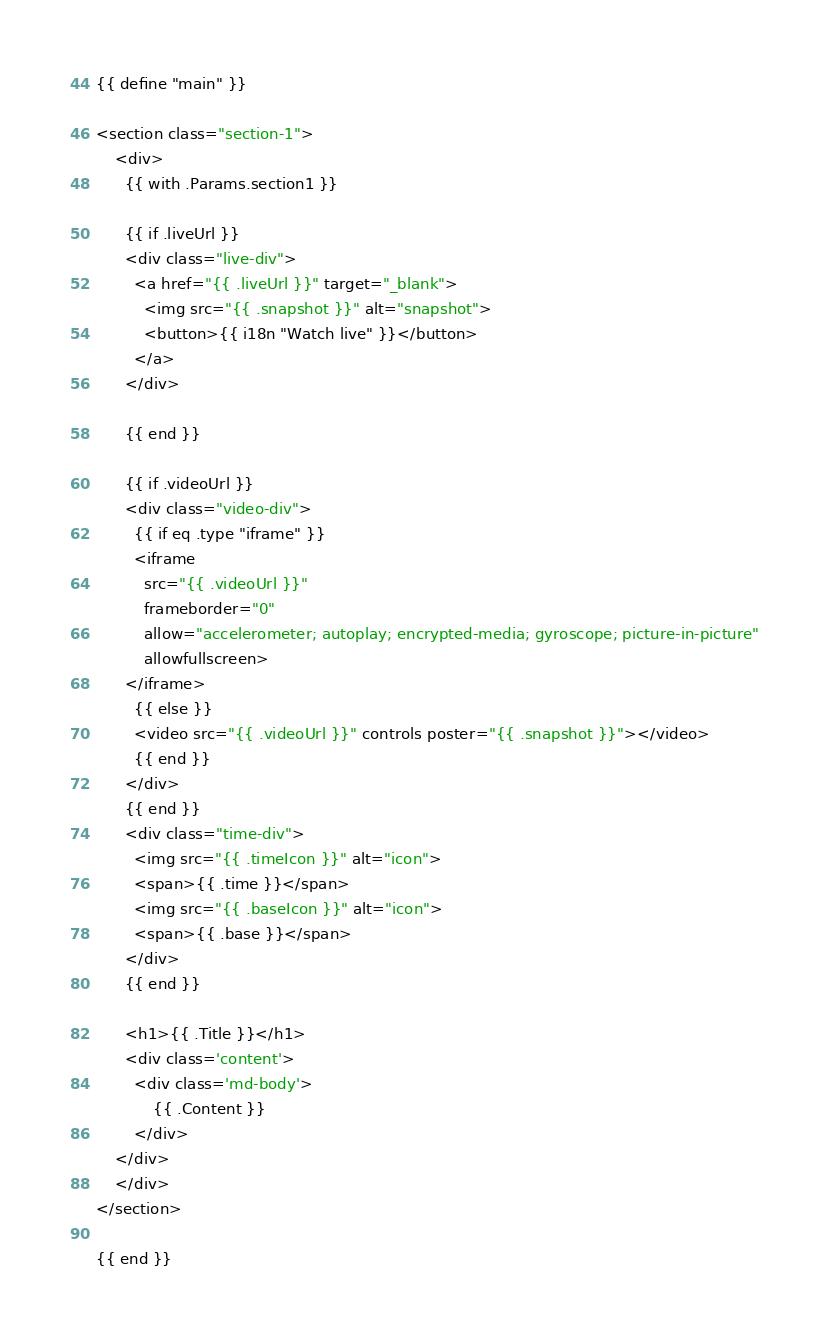<code> <loc_0><loc_0><loc_500><loc_500><_HTML_>{{ define "main" }}

<section class="section-1">
    <div>
      {{ with .Params.section1 }}

      {{ if .liveUrl }}
      <div class="live-div">
        <a href="{{ .liveUrl }}" target="_blank">
          <img src="{{ .snapshot }}" alt="snapshot">
          <button>{{ i18n "Watch live" }}</button>
        </a>
      </div>

      {{ end }}

      {{ if .videoUrl }}
      <div class="video-div">
        {{ if eq .type "iframe" }}
        <iframe 
          src="{{ .videoUrl }}" 
          frameborder="0" 
          allow="accelerometer; autoplay; encrypted-media; gyroscope; picture-in-picture" 
          allowfullscreen>
      </iframe>
        {{ else }}
        <video src="{{ .videoUrl }}" controls poster="{{ .snapshot }}"></video>
        {{ end }}
      </div>
      {{ end }}
      <div class="time-div">
        <img src="{{ .timeIcon }}" alt="icon">
        <span>{{ .time }}</span>
        <img src="{{ .baseIcon }}" alt="icon">
        <span>{{ .base }}</span>
      </div>
      {{ end }}

      <h1>{{ .Title }}</h1>
      <div class='content'>
        <div class='md-body'>
            {{ .Content }}
        </div>
    </div>
    </div>
</section>

{{ end }}</code> 